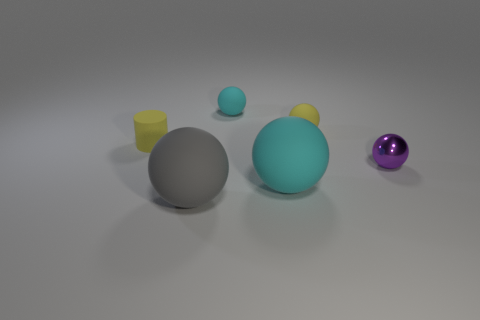Subtract 2 balls. How many balls are left? 3 Subtract all metallic balls. How many balls are left? 4 Subtract all gray balls. How many balls are left? 4 Subtract all red balls. Subtract all green blocks. How many balls are left? 5 Add 1 cyan matte spheres. How many objects exist? 7 Subtract all balls. How many objects are left? 1 Subtract all tiny cylinders. Subtract all big balls. How many objects are left? 3 Add 6 large cyan matte spheres. How many large cyan matte spheres are left? 7 Add 1 tiny metallic things. How many tiny metallic things exist? 2 Subtract 0 purple cubes. How many objects are left? 6 